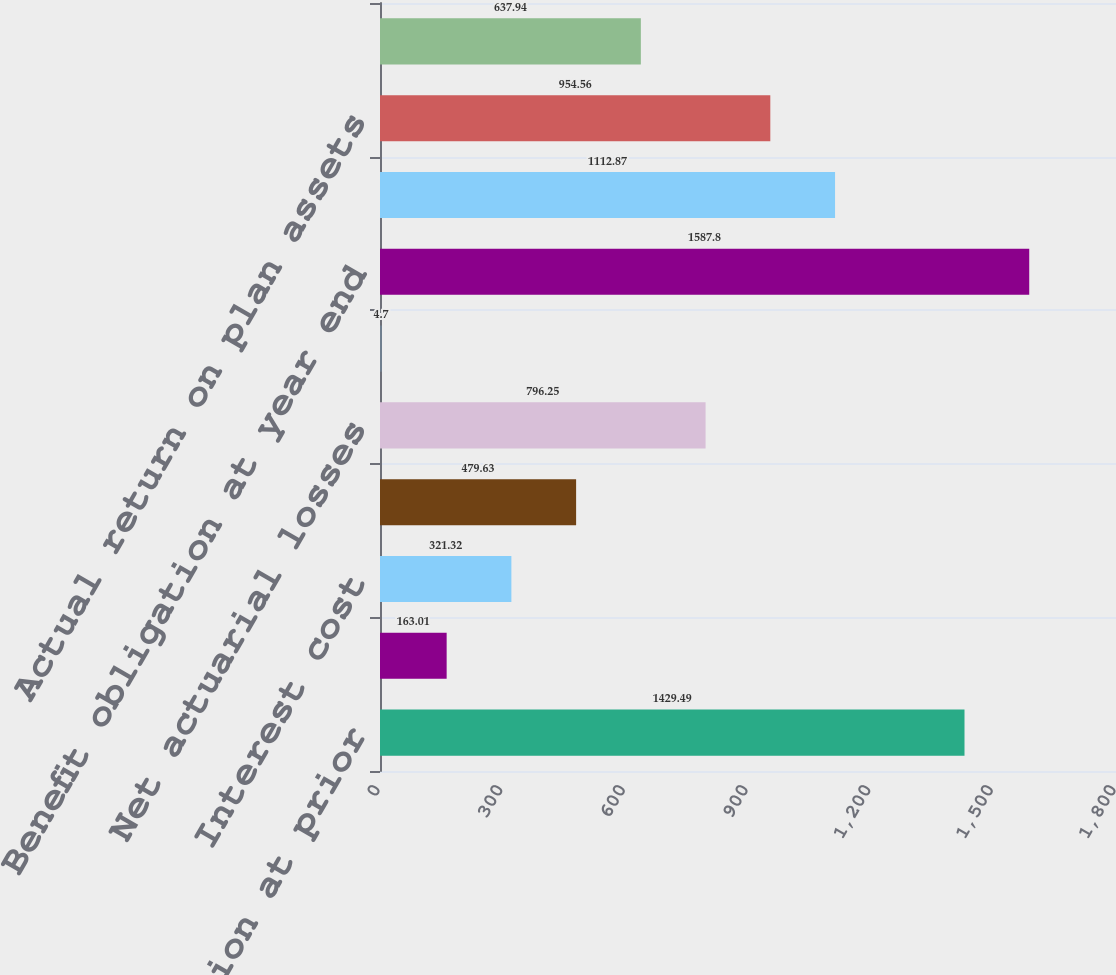<chart> <loc_0><loc_0><loc_500><loc_500><bar_chart><fcel>Benefit obligation at prior<fcel>Service cost<fcel>Interest cost<fcel>Benefits paid<fcel>Net actuarial losses<fcel>Plan amendments and other<fcel>Benefit obligation at year end<fcel>Fair value of assets at prior<fcel>Actual return on plan assets<fcel>Employer contributions<nl><fcel>1429.49<fcel>163.01<fcel>321.32<fcel>479.63<fcel>796.25<fcel>4.7<fcel>1587.8<fcel>1112.87<fcel>954.56<fcel>637.94<nl></chart> 